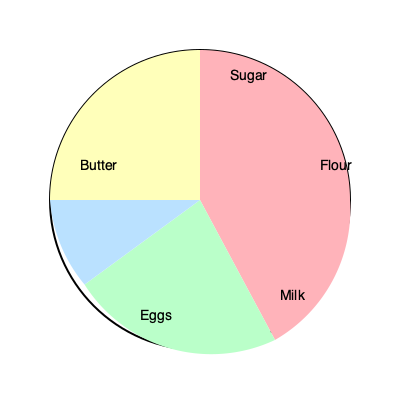A master baker is developing a new cake base recipe. The pie chart represents the ratio of ingredients by weight. If the total weight of the ingredients is 1000 grams, and the amount of flour used is 360 grams, how many grams of butter should be used in the recipe? Let's approach this step-by-step:

1) First, we need to determine what fraction of the total recipe the flour represents. From the pie chart, we can see that flour occupies $\frac{5}{12}$ of the circle (150° out of 360°).

2) We're told that 360 grams of flour is used, and this represents $\frac{5}{12}$ of the total. Let's set up an equation:

   $\frac{360 \text{ g}}{\text{Total weight}} = \frac{5}{12}$

3) We can solve this for the total weight:

   $\text{Total weight} = \frac{360 \text{ g} \times 12}{5} = 864 \text{ g}$

4) Now, we need to find out what fraction of the pie chart represents butter. It occupies $\frac{2}{12} = \frac{1}{6}$ of the circle (60° out of 360°).

5) To find the weight of butter, we multiply the total weight by the fraction representing butter:

   $\text{Butter weight} = 864 \text{ g} \times \frac{1}{6} = 144 \text{ g}$

Therefore, 144 grams of butter should be used in the recipe.
Answer: 144 grams 